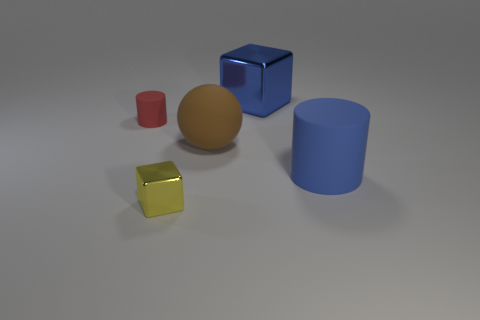Add 1 tiny rubber cylinders. How many objects exist? 6 Subtract all blocks. How many objects are left? 3 Add 2 big red matte cylinders. How many big red matte cylinders exist? 2 Subtract 0 cyan blocks. How many objects are left? 5 Subtract all tiny things. Subtract all large blue metal blocks. How many objects are left? 2 Add 4 large brown spheres. How many large brown spheres are left? 5 